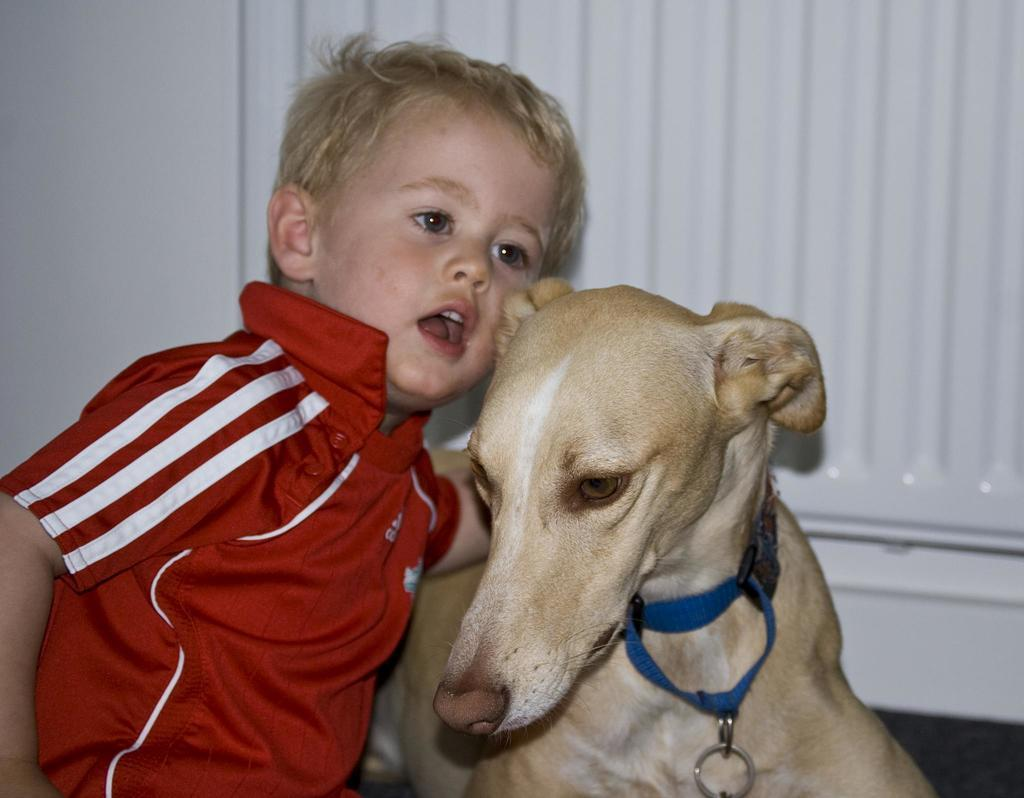What is the main subject of the image? The main subject of the image is a kid. What is the kid doing in the image? The kid is sitting beside a dog. What is the color of the background in the image? The background of the image is white. What is the tax rate for the whistle in the image? There is no whistle present in the image, and therefore no tax rate can be determined. How much profit does the dog make from the kid in the image? The image does not depict any financial transactions or profits, as it features a kid sitting beside a dog. 